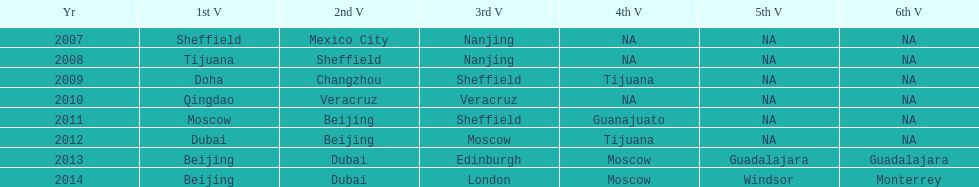Which year is previous to 2011 2010. 